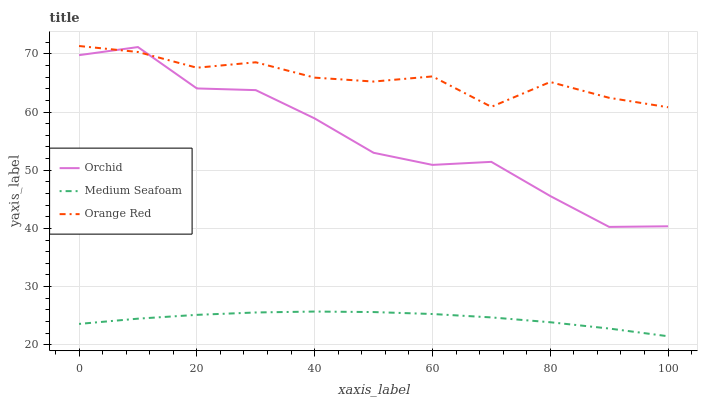Does Medium Seafoam have the minimum area under the curve?
Answer yes or no. Yes. Does Orange Red have the maximum area under the curve?
Answer yes or no. Yes. Does Orchid have the minimum area under the curve?
Answer yes or no. No. Does Orchid have the maximum area under the curve?
Answer yes or no. No. Is Medium Seafoam the smoothest?
Answer yes or no. Yes. Is Orchid the roughest?
Answer yes or no. Yes. Is Orange Red the smoothest?
Answer yes or no. No. Is Orange Red the roughest?
Answer yes or no. No. Does Medium Seafoam have the lowest value?
Answer yes or no. Yes. Does Orchid have the lowest value?
Answer yes or no. No. Does Orange Red have the highest value?
Answer yes or no. Yes. Does Orchid have the highest value?
Answer yes or no. No. Is Medium Seafoam less than Orange Red?
Answer yes or no. Yes. Is Orchid greater than Medium Seafoam?
Answer yes or no. Yes. Does Orange Red intersect Orchid?
Answer yes or no. Yes. Is Orange Red less than Orchid?
Answer yes or no. No. Is Orange Red greater than Orchid?
Answer yes or no. No. Does Medium Seafoam intersect Orange Red?
Answer yes or no. No. 